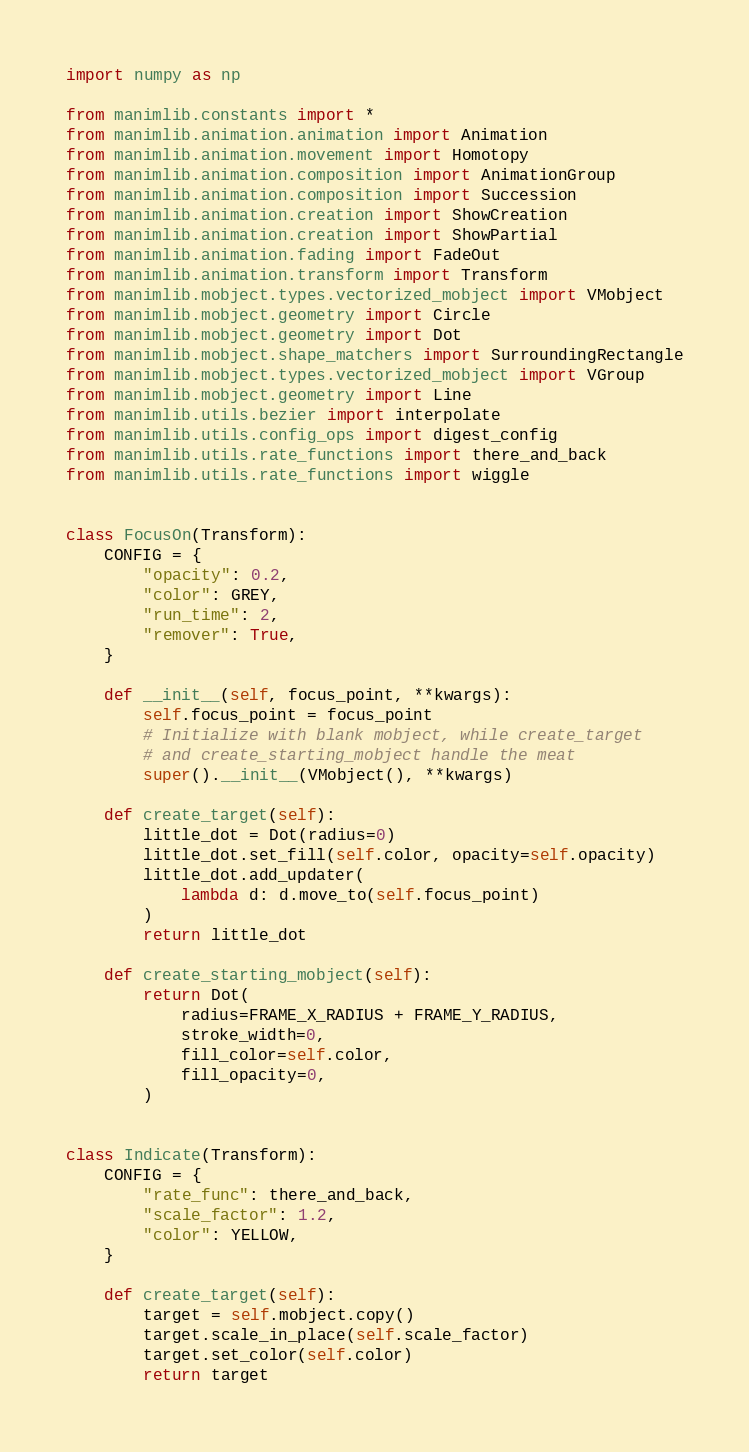<code> <loc_0><loc_0><loc_500><loc_500><_Python_>import numpy as np

from manimlib.constants import *
from manimlib.animation.animation import Animation
from manimlib.animation.movement import Homotopy
from manimlib.animation.composition import AnimationGroup
from manimlib.animation.composition import Succession
from manimlib.animation.creation import ShowCreation
from manimlib.animation.creation import ShowPartial
from manimlib.animation.fading import FadeOut
from manimlib.animation.transform import Transform
from manimlib.mobject.types.vectorized_mobject import VMobject
from manimlib.mobject.geometry import Circle
from manimlib.mobject.geometry import Dot
from manimlib.mobject.shape_matchers import SurroundingRectangle
from manimlib.mobject.types.vectorized_mobject import VGroup
from manimlib.mobject.geometry import Line
from manimlib.utils.bezier import interpolate
from manimlib.utils.config_ops import digest_config
from manimlib.utils.rate_functions import there_and_back
from manimlib.utils.rate_functions import wiggle


class FocusOn(Transform):
    CONFIG = {
        "opacity": 0.2,
        "color": GREY,
        "run_time": 2,
        "remover": True,
    }

    def __init__(self, focus_point, **kwargs):
        self.focus_point = focus_point
        # Initialize with blank mobject, while create_target
        # and create_starting_mobject handle the meat
        super().__init__(VMobject(), **kwargs)

    def create_target(self):
        little_dot = Dot(radius=0)
        little_dot.set_fill(self.color, opacity=self.opacity)
        little_dot.add_updater(
            lambda d: d.move_to(self.focus_point)
        )
        return little_dot

    def create_starting_mobject(self):
        return Dot(
            radius=FRAME_X_RADIUS + FRAME_Y_RADIUS,
            stroke_width=0,
            fill_color=self.color,
            fill_opacity=0,
        )


class Indicate(Transform):
    CONFIG = {
        "rate_func": there_and_back,
        "scale_factor": 1.2,
        "color": YELLOW,
    }

    def create_target(self):
        target = self.mobject.copy()
        target.scale_in_place(self.scale_factor)
        target.set_color(self.color)
        return target

</code> 